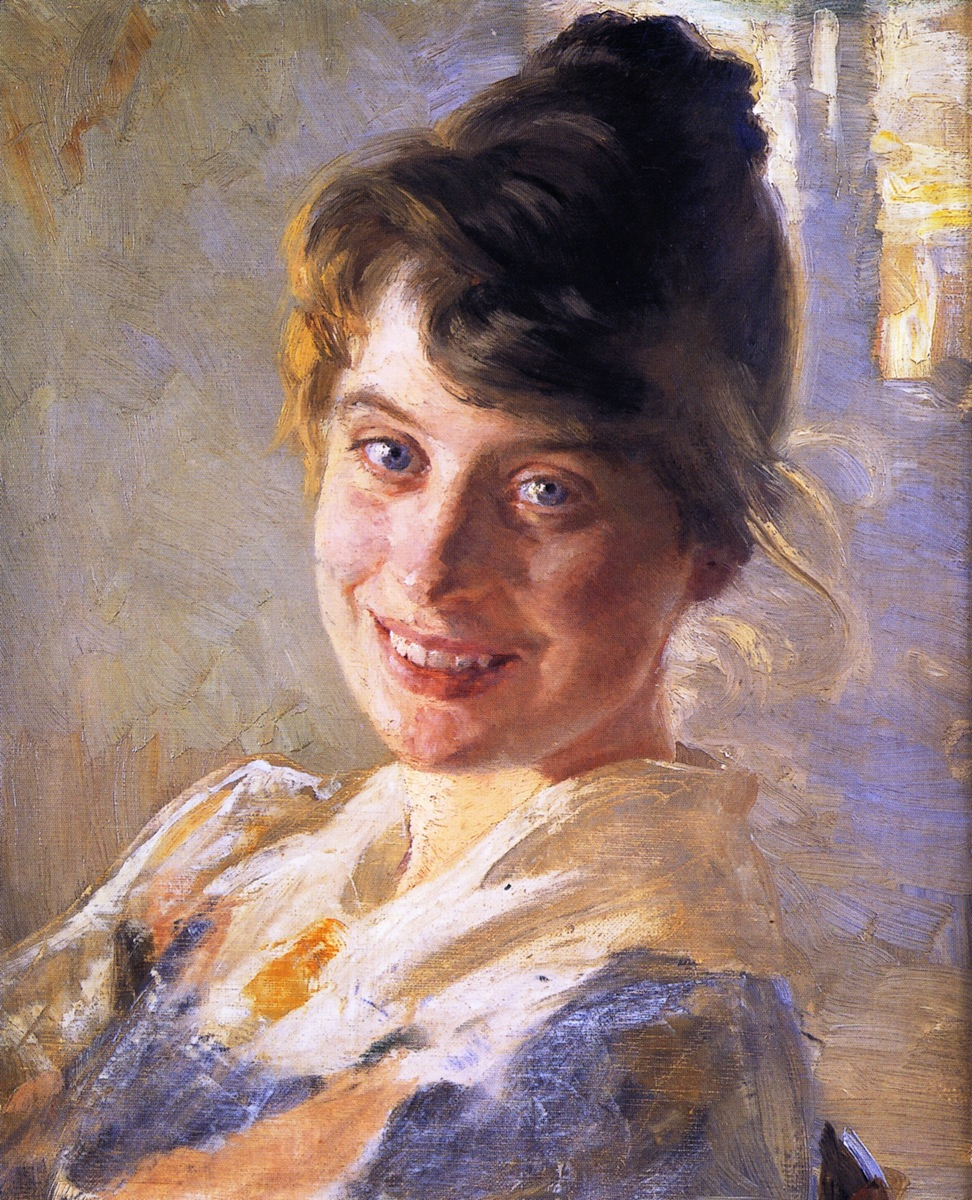What kind of setting can you imagine this woman is in, given her attire and expression? Given her attire and expression, the woman could be in a casual but inviting setting—perhaps a quaint, sunlit kitchen where she is preparing a meal for family or friends. The lighthearted smile suggests she is enjoying a moment of peace and contentment, surrounded by loved ones in a warm, homely environment. The use of light blues and yellows in the background complements this idea, evoking a cheerful and relaxed atmosphere. Recall a realistic yet detailed scenario where this portrait might hang. This portrait might hang in a cozy sitting room of a countryside cottage. The room, bathed in natural sunlight streaming through lace curtains, has walls adorned with family photographs and artwork, creating a warm and inviting ambiance. Antique wooden furniture, a plush armchair, and a fireplace with a smoldering hearth complete the scene. The painting, prominently displayed above a well-loved writing desk, serves as a focal point, eliciting smiles from all who visit. It is a symbol of the joyful home life and the special moments shared within those walls. Describe a short and realistic scenario for this image. The painting could be hanging in a small art gallery in a charming town square. Visitors are immediately drawn to the woman’s cheerful expression, and it quickly becomes a favorite piece for its warmth and playfulness. 